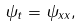Convert formula to latex. <formula><loc_0><loc_0><loc_500><loc_500>\psi _ { t } = \psi _ { x x } ,</formula> 